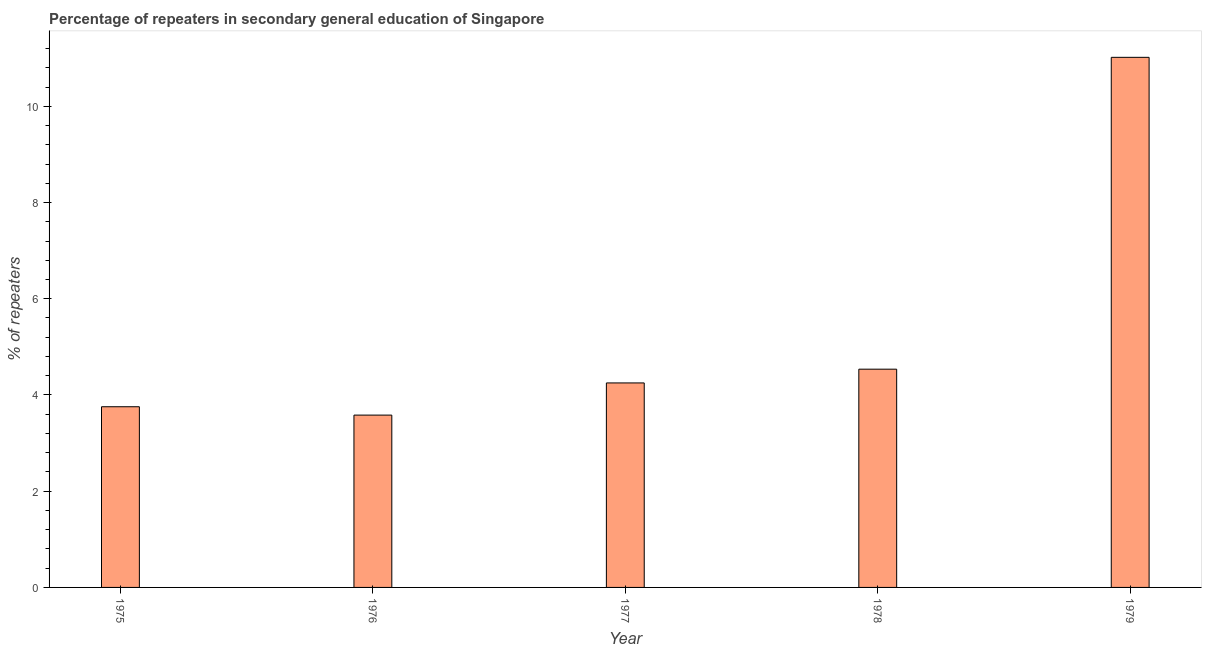What is the title of the graph?
Your answer should be very brief. Percentage of repeaters in secondary general education of Singapore. What is the label or title of the Y-axis?
Your answer should be compact. % of repeaters. What is the percentage of repeaters in 1978?
Keep it short and to the point. 4.54. Across all years, what is the maximum percentage of repeaters?
Give a very brief answer. 11.02. Across all years, what is the minimum percentage of repeaters?
Offer a very short reply. 3.58. In which year was the percentage of repeaters maximum?
Keep it short and to the point. 1979. In which year was the percentage of repeaters minimum?
Your answer should be very brief. 1976. What is the sum of the percentage of repeaters?
Provide a short and direct response. 27.14. What is the difference between the percentage of repeaters in 1977 and 1979?
Offer a very short reply. -6.77. What is the average percentage of repeaters per year?
Make the answer very short. 5.43. What is the median percentage of repeaters?
Give a very brief answer. 4.25. In how many years, is the percentage of repeaters greater than 8.8 %?
Give a very brief answer. 1. Do a majority of the years between 1976 and 1978 (inclusive) have percentage of repeaters greater than 6.4 %?
Your answer should be very brief. No. What is the ratio of the percentage of repeaters in 1978 to that in 1979?
Your answer should be very brief. 0.41. Is the percentage of repeaters in 1975 less than that in 1977?
Ensure brevity in your answer.  Yes. What is the difference between the highest and the second highest percentage of repeaters?
Make the answer very short. 6.48. Is the sum of the percentage of repeaters in 1975 and 1979 greater than the maximum percentage of repeaters across all years?
Ensure brevity in your answer.  Yes. What is the difference between the highest and the lowest percentage of repeaters?
Your answer should be very brief. 7.44. In how many years, is the percentage of repeaters greater than the average percentage of repeaters taken over all years?
Provide a short and direct response. 1. Are all the bars in the graph horizontal?
Make the answer very short. No. How many years are there in the graph?
Keep it short and to the point. 5. What is the difference between two consecutive major ticks on the Y-axis?
Ensure brevity in your answer.  2. Are the values on the major ticks of Y-axis written in scientific E-notation?
Make the answer very short. No. What is the % of repeaters in 1975?
Offer a very short reply. 3.76. What is the % of repeaters in 1976?
Give a very brief answer. 3.58. What is the % of repeaters in 1977?
Provide a short and direct response. 4.25. What is the % of repeaters of 1978?
Give a very brief answer. 4.54. What is the % of repeaters in 1979?
Your answer should be compact. 11.02. What is the difference between the % of repeaters in 1975 and 1976?
Your answer should be compact. 0.17. What is the difference between the % of repeaters in 1975 and 1977?
Your answer should be compact. -0.49. What is the difference between the % of repeaters in 1975 and 1978?
Offer a very short reply. -0.78. What is the difference between the % of repeaters in 1975 and 1979?
Your answer should be compact. -7.26. What is the difference between the % of repeaters in 1976 and 1977?
Provide a short and direct response. -0.67. What is the difference between the % of repeaters in 1976 and 1978?
Provide a short and direct response. -0.95. What is the difference between the % of repeaters in 1976 and 1979?
Keep it short and to the point. -7.44. What is the difference between the % of repeaters in 1977 and 1978?
Your response must be concise. -0.29. What is the difference between the % of repeaters in 1977 and 1979?
Provide a succinct answer. -6.77. What is the difference between the % of repeaters in 1978 and 1979?
Ensure brevity in your answer.  -6.48. What is the ratio of the % of repeaters in 1975 to that in 1976?
Your answer should be very brief. 1.05. What is the ratio of the % of repeaters in 1975 to that in 1977?
Your answer should be very brief. 0.88. What is the ratio of the % of repeaters in 1975 to that in 1978?
Offer a terse response. 0.83. What is the ratio of the % of repeaters in 1975 to that in 1979?
Your answer should be very brief. 0.34. What is the ratio of the % of repeaters in 1976 to that in 1977?
Make the answer very short. 0.84. What is the ratio of the % of repeaters in 1976 to that in 1978?
Offer a very short reply. 0.79. What is the ratio of the % of repeaters in 1976 to that in 1979?
Ensure brevity in your answer.  0.33. What is the ratio of the % of repeaters in 1977 to that in 1978?
Give a very brief answer. 0.94. What is the ratio of the % of repeaters in 1977 to that in 1979?
Provide a succinct answer. 0.39. What is the ratio of the % of repeaters in 1978 to that in 1979?
Your response must be concise. 0.41. 